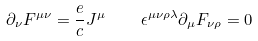<formula> <loc_0><loc_0><loc_500><loc_500>\partial _ { \nu } F ^ { \mu \nu } = \frac { e } { c } J ^ { \mu } \quad \epsilon ^ { \mu \nu \rho \lambda } \partial _ { \mu } F _ { \nu \rho } = 0</formula> 